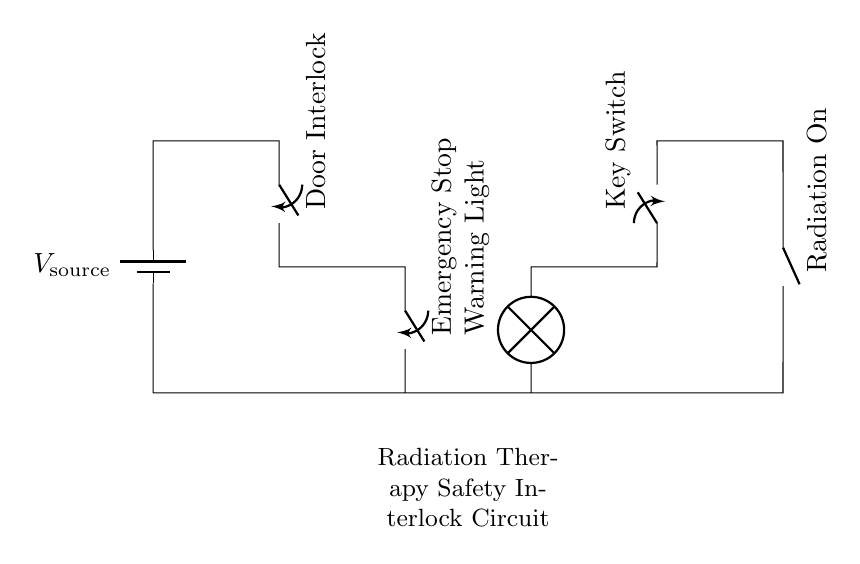What is the main purpose of the switches in this circuit? The switches serve as interlocks that control the safety mechanisms of the radiation therapy equipment, ensuring that the radiation is only enabled under safe conditions.
Answer: safety mechanisms What component emits a warning signal in the circuit? The circuit includes a warning light which activates to alert users when a critical event occurs, such as the radiation being turned on.
Answer: Warning Light How many switches are present in the circuit? There are three switches depicted in the circuit: the Door Interlock, Emergency Stop, and Key Switch. Each of these plays a role in controlling access and operation of the radiation machine.
Answer: three Which switch is located closest to the radiation source? The Key Switch is the last one in the circuit before the radiation source, indicating that it directly controls the initiation of radiation output.
Answer: Key Switch What does the emergency stop switch do in this circuit? The Emergency Stop switch provides an immediate means to halt operations, ensuring safety by allowing for a quick shutdown in case of an emergency or malfunction.
Answer: halt operations If the Door Interlock is open, what happens to the circuit? If the Door Interlock is open, the circuit becomes incomplete, preventing any current flow and thereby ensuring that the radiation cannot be turned on under unsafe conditions.
Answer: incomplete circuit 